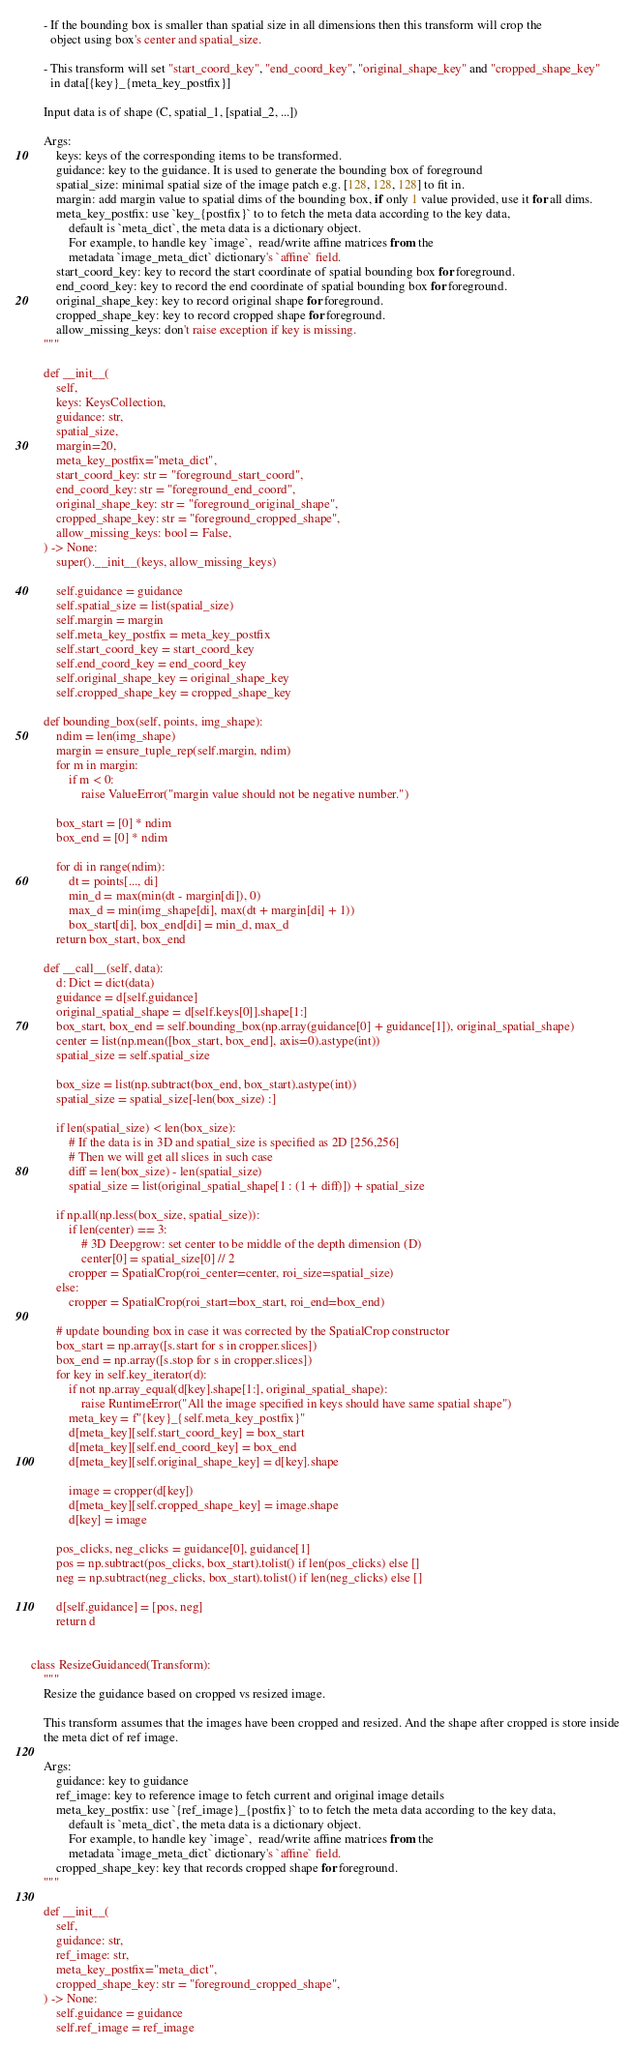<code> <loc_0><loc_0><loc_500><loc_500><_Python_>    - If the bounding box is smaller than spatial size in all dimensions then this transform will crop the
      object using box's center and spatial_size.

    - This transform will set "start_coord_key", "end_coord_key", "original_shape_key" and "cropped_shape_key"
      in data[{key}_{meta_key_postfix}]

    Input data is of shape (C, spatial_1, [spatial_2, ...])

    Args:
        keys: keys of the corresponding items to be transformed.
        guidance: key to the guidance. It is used to generate the bounding box of foreground
        spatial_size: minimal spatial size of the image patch e.g. [128, 128, 128] to fit in.
        margin: add margin value to spatial dims of the bounding box, if only 1 value provided, use it for all dims.
        meta_key_postfix: use `key_{postfix}` to to fetch the meta data according to the key data,
            default is `meta_dict`, the meta data is a dictionary object.
            For example, to handle key `image`,  read/write affine matrices from the
            metadata `image_meta_dict` dictionary's `affine` field.
        start_coord_key: key to record the start coordinate of spatial bounding box for foreground.
        end_coord_key: key to record the end coordinate of spatial bounding box for foreground.
        original_shape_key: key to record original shape for foreground.
        cropped_shape_key: key to record cropped shape for foreground.
        allow_missing_keys: don't raise exception if key is missing.
    """

    def __init__(
        self,
        keys: KeysCollection,
        guidance: str,
        spatial_size,
        margin=20,
        meta_key_postfix="meta_dict",
        start_coord_key: str = "foreground_start_coord",
        end_coord_key: str = "foreground_end_coord",
        original_shape_key: str = "foreground_original_shape",
        cropped_shape_key: str = "foreground_cropped_shape",
        allow_missing_keys: bool = False,
    ) -> None:
        super().__init__(keys, allow_missing_keys)

        self.guidance = guidance
        self.spatial_size = list(spatial_size)
        self.margin = margin
        self.meta_key_postfix = meta_key_postfix
        self.start_coord_key = start_coord_key
        self.end_coord_key = end_coord_key
        self.original_shape_key = original_shape_key
        self.cropped_shape_key = cropped_shape_key

    def bounding_box(self, points, img_shape):
        ndim = len(img_shape)
        margin = ensure_tuple_rep(self.margin, ndim)
        for m in margin:
            if m < 0:
                raise ValueError("margin value should not be negative number.")

        box_start = [0] * ndim
        box_end = [0] * ndim

        for di in range(ndim):
            dt = points[..., di]
            min_d = max(min(dt - margin[di]), 0)
            max_d = min(img_shape[di], max(dt + margin[di] + 1))
            box_start[di], box_end[di] = min_d, max_d
        return box_start, box_end

    def __call__(self, data):
        d: Dict = dict(data)
        guidance = d[self.guidance]
        original_spatial_shape = d[self.keys[0]].shape[1:]
        box_start, box_end = self.bounding_box(np.array(guidance[0] + guidance[1]), original_spatial_shape)
        center = list(np.mean([box_start, box_end], axis=0).astype(int))
        spatial_size = self.spatial_size

        box_size = list(np.subtract(box_end, box_start).astype(int))
        spatial_size = spatial_size[-len(box_size) :]

        if len(spatial_size) < len(box_size):
            # If the data is in 3D and spatial_size is specified as 2D [256,256]
            # Then we will get all slices in such case
            diff = len(box_size) - len(spatial_size)
            spatial_size = list(original_spatial_shape[1 : (1 + diff)]) + spatial_size

        if np.all(np.less(box_size, spatial_size)):
            if len(center) == 3:
                # 3D Deepgrow: set center to be middle of the depth dimension (D)
                center[0] = spatial_size[0] // 2
            cropper = SpatialCrop(roi_center=center, roi_size=spatial_size)
        else:
            cropper = SpatialCrop(roi_start=box_start, roi_end=box_end)

        # update bounding box in case it was corrected by the SpatialCrop constructor
        box_start = np.array([s.start for s in cropper.slices])
        box_end = np.array([s.stop for s in cropper.slices])
        for key in self.key_iterator(d):
            if not np.array_equal(d[key].shape[1:], original_spatial_shape):
                raise RuntimeError("All the image specified in keys should have same spatial shape")
            meta_key = f"{key}_{self.meta_key_postfix}"
            d[meta_key][self.start_coord_key] = box_start
            d[meta_key][self.end_coord_key] = box_end
            d[meta_key][self.original_shape_key] = d[key].shape

            image = cropper(d[key])
            d[meta_key][self.cropped_shape_key] = image.shape
            d[key] = image

        pos_clicks, neg_clicks = guidance[0], guidance[1]
        pos = np.subtract(pos_clicks, box_start).tolist() if len(pos_clicks) else []
        neg = np.subtract(neg_clicks, box_start).tolist() if len(neg_clicks) else []

        d[self.guidance] = [pos, neg]
        return d


class ResizeGuidanced(Transform):
    """
    Resize the guidance based on cropped vs resized image.

    This transform assumes that the images have been cropped and resized. And the shape after cropped is store inside
    the meta dict of ref image.

    Args:
        guidance: key to guidance
        ref_image: key to reference image to fetch current and original image details
        meta_key_postfix: use `{ref_image}_{postfix}` to to fetch the meta data according to the key data,
            default is `meta_dict`, the meta data is a dictionary object.
            For example, to handle key `image`,  read/write affine matrices from the
            metadata `image_meta_dict` dictionary's `affine` field.
        cropped_shape_key: key that records cropped shape for foreground.
    """

    def __init__(
        self,
        guidance: str,
        ref_image: str,
        meta_key_postfix="meta_dict",
        cropped_shape_key: str = "foreground_cropped_shape",
    ) -> None:
        self.guidance = guidance
        self.ref_image = ref_image</code> 